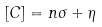<formula> <loc_0><loc_0><loc_500><loc_500>[ C ] = n \sigma + \eta</formula> 